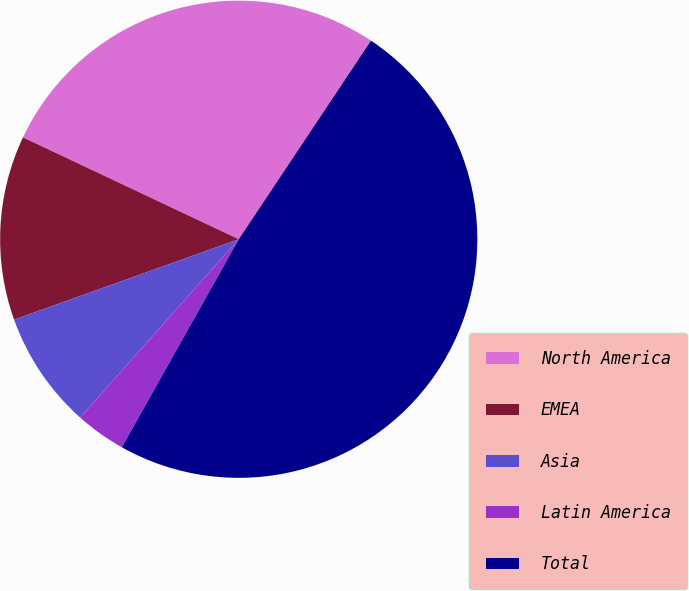Convert chart. <chart><loc_0><loc_0><loc_500><loc_500><pie_chart><fcel>North America<fcel>EMEA<fcel>Asia<fcel>Latin America<fcel>Total<nl><fcel>27.33%<fcel>12.49%<fcel>7.96%<fcel>3.42%<fcel>48.8%<nl></chart> 